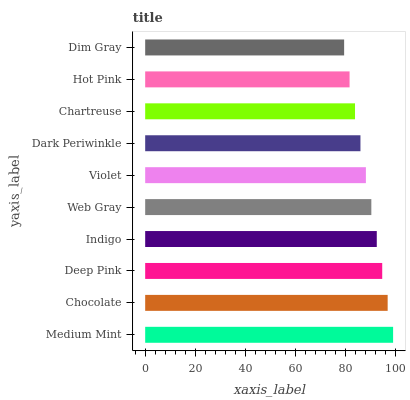Is Dim Gray the minimum?
Answer yes or no. Yes. Is Medium Mint the maximum?
Answer yes or no. Yes. Is Chocolate the minimum?
Answer yes or no. No. Is Chocolate the maximum?
Answer yes or no. No. Is Medium Mint greater than Chocolate?
Answer yes or no. Yes. Is Chocolate less than Medium Mint?
Answer yes or no. Yes. Is Chocolate greater than Medium Mint?
Answer yes or no. No. Is Medium Mint less than Chocolate?
Answer yes or no. No. Is Web Gray the high median?
Answer yes or no. Yes. Is Violet the low median?
Answer yes or no. Yes. Is Chocolate the high median?
Answer yes or no. No. Is Indigo the low median?
Answer yes or no. No. 